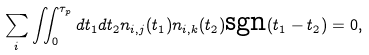<formula> <loc_0><loc_0><loc_500><loc_500>\sum _ { i } \iint _ { 0 } ^ { \tau _ { p } } d t _ { 1 } d t _ { 2 } n _ { i , j } ( t _ { 1 } ) n _ { i , k } ( t _ { 2 } ) \text {sgn} ( t _ { 1 } - t _ { 2 } ) = 0 ,</formula> 